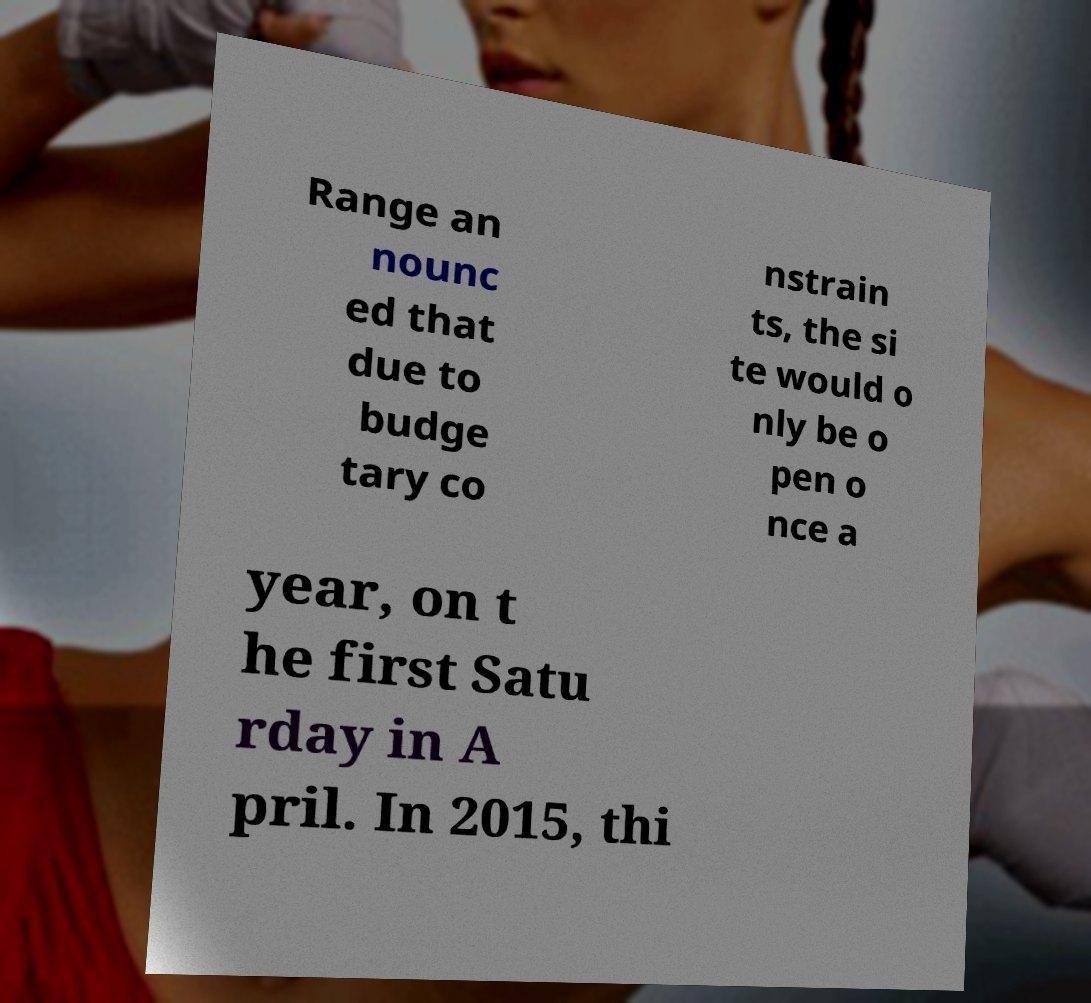I need the written content from this picture converted into text. Can you do that? Range an nounc ed that due to budge tary co nstrain ts, the si te would o nly be o pen o nce a year, on t he first Satu rday in A pril. In 2015, thi 